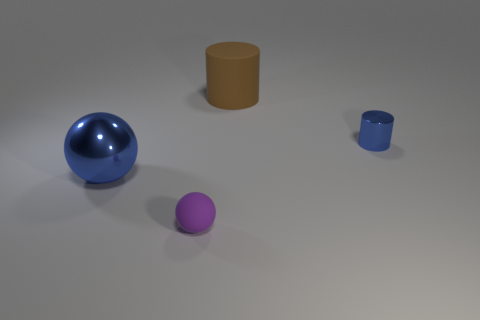Are there more matte cylinders on the left side of the small matte sphere than purple things that are behind the large sphere? After carefully examining the image, I can confirm that there are no purple objects behind the large sphere, and there is just one matte cylinder on the left side of the small matte sphere. Therefore, it's accurate to say that there are more matte cylinders on the left side of the small matte sphere than purple things behind the large sphere, as the latter count is zero. 